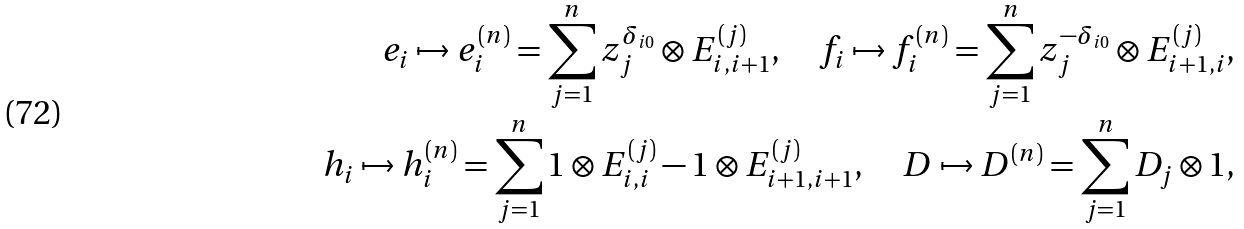<formula> <loc_0><loc_0><loc_500><loc_500>e _ { i } \mapsto e _ { i } ^ { ( n ) } = \sum _ { j = 1 } ^ { n } z _ { j } ^ { \delta _ { i 0 } } \otimes E _ { i , i + 1 } ^ { ( j ) } , \quad f _ { i } \mapsto f _ { i } ^ { ( n ) } = \sum _ { j = 1 } ^ { n } z _ { j } ^ { - \delta _ { i 0 } } \otimes E _ { i + 1 , i } ^ { ( j ) } , \\ h _ { i } \mapsto h _ { i } ^ { ( n ) } = \sum _ { j = 1 } ^ { n } 1 \otimes E _ { i , i } ^ { ( j ) } - 1 \otimes E _ { i + 1 , i + 1 } ^ { ( j ) } , \quad D \mapsto D ^ { ( n ) } = \sum _ { j = 1 } ^ { n } D _ { j } \otimes 1 ,</formula> 